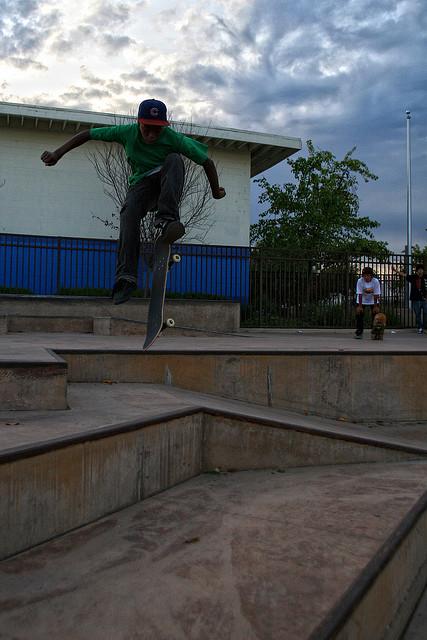Is the sky cloudy?
Answer briefly. Yes. Is this skateboarder wearing a helmet?
Keep it brief. No. Will the skateboarder complete the jump successfully?
Quick response, please. No. What type of wall is behind the skateboarder?
Give a very brief answer. Concrete. 